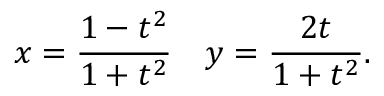Convert formula to latex. <formula><loc_0><loc_0><loc_500><loc_500>x = { \frac { 1 - t ^ { 2 } } { 1 + t ^ { 2 } } } \quad y = { \frac { 2 t } { 1 + t ^ { 2 } } } .</formula> 